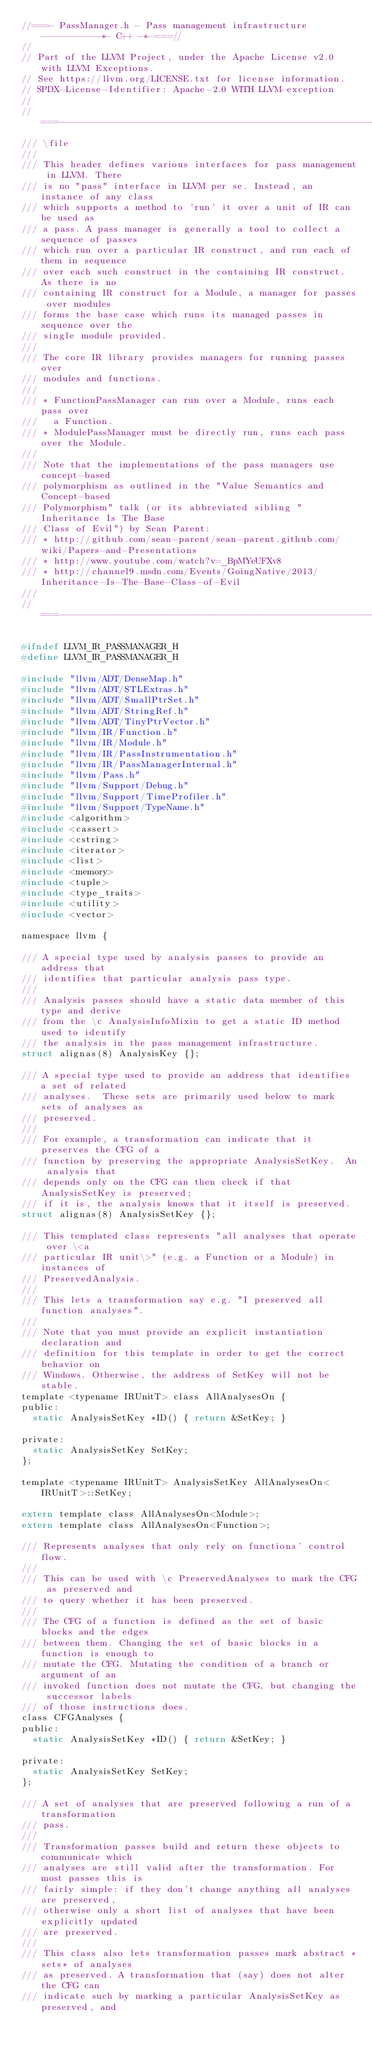Convert code to text. <code><loc_0><loc_0><loc_500><loc_500><_C_>//===- PassManager.h - Pass management infrastructure -----------*- C++ -*-===//
//
// Part of the LLVM Project, under the Apache License v2.0 with LLVM Exceptions.
// See https://llvm.org/LICENSE.txt for license information.
// SPDX-License-Identifier: Apache-2.0 WITH LLVM-exception
//
//===----------------------------------------------------------------------===//
/// \file
///
/// This header defines various interfaces for pass management in LLVM. There
/// is no "pass" interface in LLVM per se. Instead, an instance of any class
/// which supports a method to 'run' it over a unit of IR can be used as
/// a pass. A pass manager is generally a tool to collect a sequence of passes
/// which run over a particular IR construct, and run each of them in sequence
/// over each such construct in the containing IR construct. As there is no
/// containing IR construct for a Module, a manager for passes over modules
/// forms the base case which runs its managed passes in sequence over the
/// single module provided.
///
/// The core IR library provides managers for running passes over
/// modules and functions.
///
/// * FunctionPassManager can run over a Module, runs each pass over
///   a Function.
/// * ModulePassManager must be directly run, runs each pass over the Module.
///
/// Note that the implementations of the pass managers use concept-based
/// polymorphism as outlined in the "Value Semantics and Concept-based
/// Polymorphism" talk (or its abbreviated sibling "Inheritance Is The Base
/// Class of Evil") by Sean Parent:
/// * http://github.com/sean-parent/sean-parent.github.com/wiki/Papers-and-Presentations
/// * http://www.youtube.com/watch?v=_BpMYeUFXv8
/// * http://channel9.msdn.com/Events/GoingNative/2013/Inheritance-Is-The-Base-Class-of-Evil
///
//===----------------------------------------------------------------------===//

#ifndef LLVM_IR_PASSMANAGER_H
#define LLVM_IR_PASSMANAGER_H

#include "llvm/ADT/DenseMap.h"
#include "llvm/ADT/STLExtras.h"
#include "llvm/ADT/SmallPtrSet.h"
#include "llvm/ADT/StringRef.h"
#include "llvm/ADT/TinyPtrVector.h"
#include "llvm/IR/Function.h"
#include "llvm/IR/Module.h"
#include "llvm/IR/PassInstrumentation.h"
#include "llvm/IR/PassManagerInternal.h"
#include "llvm/Pass.h"
#include "llvm/Support/Debug.h"
#include "llvm/Support/TimeProfiler.h"
#include "llvm/Support/TypeName.h"
#include <algorithm>
#include <cassert>
#include <cstring>
#include <iterator>
#include <list>
#include <memory>
#include <tuple>
#include <type_traits>
#include <utility>
#include <vector>

namespace llvm {

/// A special type used by analysis passes to provide an address that
/// identifies that particular analysis pass type.
///
/// Analysis passes should have a static data member of this type and derive
/// from the \c AnalysisInfoMixin to get a static ID method used to identify
/// the analysis in the pass management infrastructure.
struct alignas(8) AnalysisKey {};

/// A special type used to provide an address that identifies a set of related
/// analyses.  These sets are primarily used below to mark sets of analyses as
/// preserved.
///
/// For example, a transformation can indicate that it preserves the CFG of a
/// function by preserving the appropriate AnalysisSetKey.  An analysis that
/// depends only on the CFG can then check if that AnalysisSetKey is preserved;
/// if it is, the analysis knows that it itself is preserved.
struct alignas(8) AnalysisSetKey {};

/// This templated class represents "all analyses that operate over \<a
/// particular IR unit\>" (e.g. a Function or a Module) in instances of
/// PreservedAnalysis.
///
/// This lets a transformation say e.g. "I preserved all function analyses".
///
/// Note that you must provide an explicit instantiation declaration and
/// definition for this template in order to get the correct behavior on
/// Windows. Otherwise, the address of SetKey will not be stable.
template <typename IRUnitT> class AllAnalysesOn {
public:
  static AnalysisSetKey *ID() { return &SetKey; }

private:
  static AnalysisSetKey SetKey;
};

template <typename IRUnitT> AnalysisSetKey AllAnalysesOn<IRUnitT>::SetKey;

extern template class AllAnalysesOn<Module>;
extern template class AllAnalysesOn<Function>;

/// Represents analyses that only rely on functions' control flow.
///
/// This can be used with \c PreservedAnalyses to mark the CFG as preserved and
/// to query whether it has been preserved.
///
/// The CFG of a function is defined as the set of basic blocks and the edges
/// between them. Changing the set of basic blocks in a function is enough to
/// mutate the CFG. Mutating the condition of a branch or argument of an
/// invoked function does not mutate the CFG, but changing the successor labels
/// of those instructions does.
class CFGAnalyses {
public:
  static AnalysisSetKey *ID() { return &SetKey; }

private:
  static AnalysisSetKey SetKey;
};

/// A set of analyses that are preserved following a run of a transformation
/// pass.
///
/// Transformation passes build and return these objects to communicate which
/// analyses are still valid after the transformation. For most passes this is
/// fairly simple: if they don't change anything all analyses are preserved,
/// otherwise only a short list of analyses that have been explicitly updated
/// are preserved.
///
/// This class also lets transformation passes mark abstract *sets* of analyses
/// as preserved. A transformation that (say) does not alter the CFG can
/// indicate such by marking a particular AnalysisSetKey as preserved, and</code> 